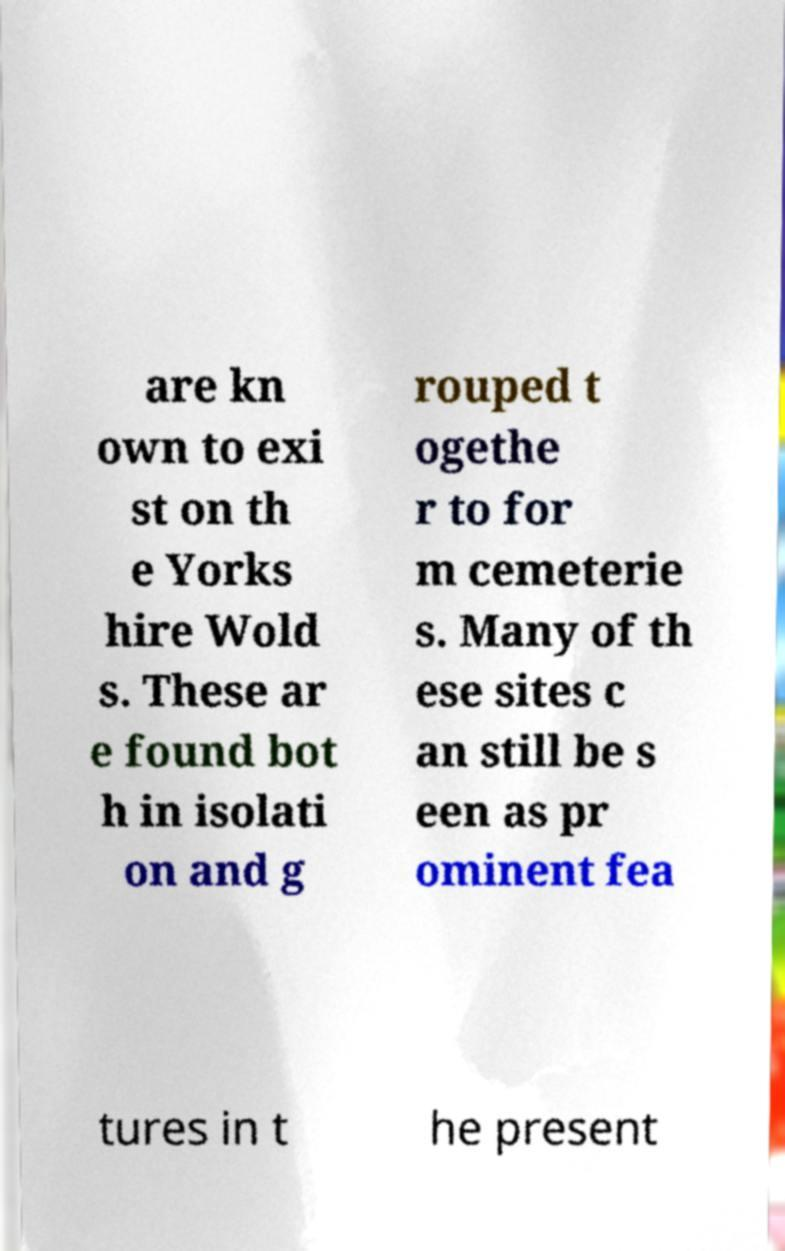What messages or text are displayed in this image? I need them in a readable, typed format. are kn own to exi st on th e Yorks hire Wold s. These ar e found bot h in isolati on and g rouped t ogethe r to for m cemeterie s. Many of th ese sites c an still be s een as pr ominent fea tures in t he present 